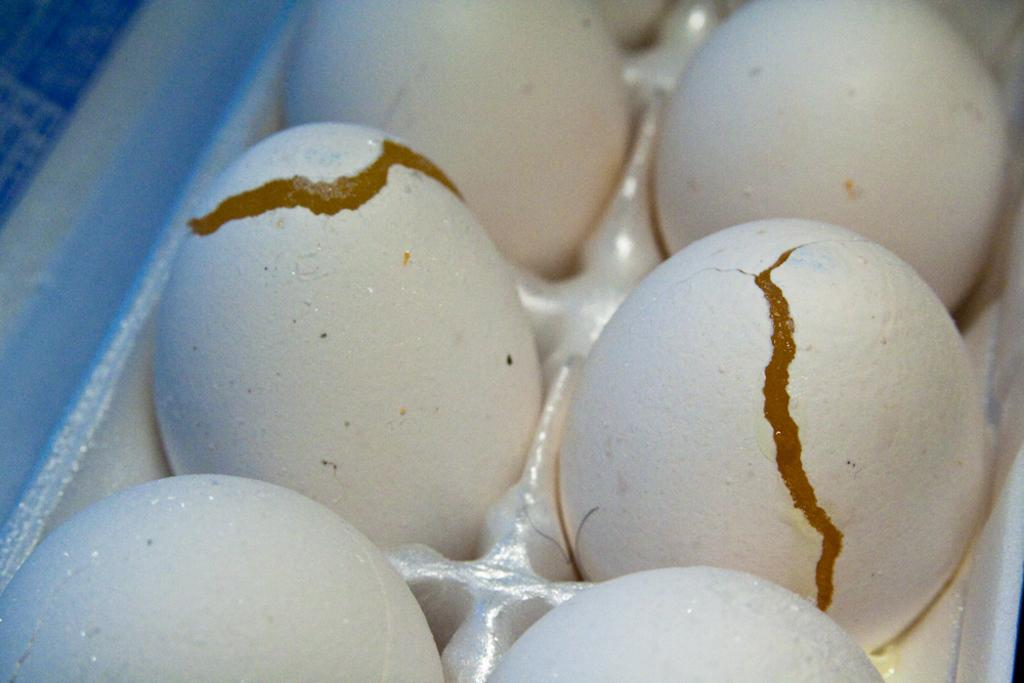How many eggs are visible in the image? There are six eggs in the image, four of which are normal and two of which are half-broken. What is the condition of the eggs in the image? Two of the eggs are half-broken, while the other four are normal. Where are the eggs located in the image? The eggs are in a case. What type of flame can be seen coming from the kettle in the image? There is no kettle or flame present in the image; it only features eggs in a case. 